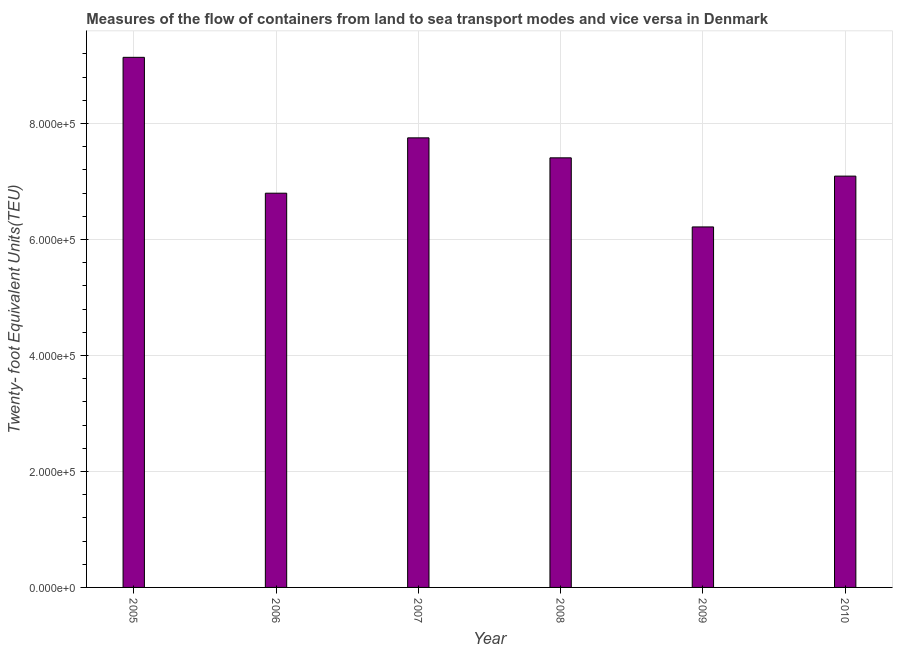Does the graph contain grids?
Ensure brevity in your answer.  Yes. What is the title of the graph?
Keep it short and to the point. Measures of the flow of containers from land to sea transport modes and vice versa in Denmark. What is the label or title of the X-axis?
Your answer should be very brief. Year. What is the label or title of the Y-axis?
Your response must be concise. Twenty- foot Equivalent Units(TEU). What is the container port traffic in 2007?
Ensure brevity in your answer.  7.75e+05. Across all years, what is the maximum container port traffic?
Your answer should be compact. 9.14e+05. Across all years, what is the minimum container port traffic?
Offer a very short reply. 6.22e+05. In which year was the container port traffic maximum?
Keep it short and to the point. 2005. What is the sum of the container port traffic?
Make the answer very short. 4.44e+06. What is the difference between the container port traffic in 2008 and 2009?
Your answer should be compact. 1.19e+05. What is the average container port traffic per year?
Offer a terse response. 7.40e+05. What is the median container port traffic?
Make the answer very short. 7.25e+05. In how many years, is the container port traffic greater than 160000 TEU?
Offer a terse response. 6. What is the ratio of the container port traffic in 2008 to that in 2009?
Offer a very short reply. 1.19. What is the difference between the highest and the second highest container port traffic?
Offer a terse response. 1.39e+05. What is the difference between the highest and the lowest container port traffic?
Keep it short and to the point. 2.92e+05. How many bars are there?
Ensure brevity in your answer.  6. Are all the bars in the graph horizontal?
Your answer should be compact. No. How many years are there in the graph?
Make the answer very short. 6. What is the Twenty- foot Equivalent Units(TEU) of 2005?
Give a very brief answer. 9.14e+05. What is the Twenty- foot Equivalent Units(TEU) of 2006?
Offer a very short reply. 6.80e+05. What is the Twenty- foot Equivalent Units(TEU) of 2007?
Your answer should be very brief. 7.75e+05. What is the Twenty- foot Equivalent Units(TEU) in 2008?
Your response must be concise. 7.41e+05. What is the Twenty- foot Equivalent Units(TEU) in 2009?
Provide a short and direct response. 6.22e+05. What is the Twenty- foot Equivalent Units(TEU) of 2010?
Offer a very short reply. 7.09e+05. What is the difference between the Twenty- foot Equivalent Units(TEU) in 2005 and 2006?
Ensure brevity in your answer.  2.34e+05. What is the difference between the Twenty- foot Equivalent Units(TEU) in 2005 and 2007?
Your answer should be compact. 1.39e+05. What is the difference between the Twenty- foot Equivalent Units(TEU) in 2005 and 2008?
Your response must be concise. 1.73e+05. What is the difference between the Twenty- foot Equivalent Units(TEU) in 2005 and 2009?
Offer a terse response. 2.92e+05. What is the difference between the Twenty- foot Equivalent Units(TEU) in 2005 and 2010?
Your answer should be very brief. 2.05e+05. What is the difference between the Twenty- foot Equivalent Units(TEU) in 2006 and 2007?
Make the answer very short. -9.54e+04. What is the difference between the Twenty- foot Equivalent Units(TEU) in 2006 and 2008?
Your answer should be compact. -6.10e+04. What is the difference between the Twenty- foot Equivalent Units(TEU) in 2006 and 2009?
Your answer should be very brief. 5.82e+04. What is the difference between the Twenty- foot Equivalent Units(TEU) in 2006 and 2010?
Offer a terse response. -2.94e+04. What is the difference between the Twenty- foot Equivalent Units(TEU) in 2007 and 2008?
Your response must be concise. 3.44e+04. What is the difference between the Twenty- foot Equivalent Units(TEU) in 2007 and 2009?
Your response must be concise. 1.54e+05. What is the difference between the Twenty- foot Equivalent Units(TEU) in 2007 and 2010?
Provide a succinct answer. 6.60e+04. What is the difference between the Twenty- foot Equivalent Units(TEU) in 2008 and 2009?
Provide a short and direct response. 1.19e+05. What is the difference between the Twenty- foot Equivalent Units(TEU) in 2008 and 2010?
Give a very brief answer. 3.15e+04. What is the difference between the Twenty- foot Equivalent Units(TEU) in 2009 and 2010?
Offer a terse response. -8.76e+04. What is the ratio of the Twenty- foot Equivalent Units(TEU) in 2005 to that in 2006?
Give a very brief answer. 1.34. What is the ratio of the Twenty- foot Equivalent Units(TEU) in 2005 to that in 2007?
Offer a very short reply. 1.18. What is the ratio of the Twenty- foot Equivalent Units(TEU) in 2005 to that in 2008?
Provide a succinct answer. 1.23. What is the ratio of the Twenty- foot Equivalent Units(TEU) in 2005 to that in 2009?
Provide a short and direct response. 1.47. What is the ratio of the Twenty- foot Equivalent Units(TEU) in 2005 to that in 2010?
Provide a succinct answer. 1.29. What is the ratio of the Twenty- foot Equivalent Units(TEU) in 2006 to that in 2007?
Give a very brief answer. 0.88. What is the ratio of the Twenty- foot Equivalent Units(TEU) in 2006 to that in 2008?
Offer a very short reply. 0.92. What is the ratio of the Twenty- foot Equivalent Units(TEU) in 2006 to that in 2009?
Offer a very short reply. 1.09. What is the ratio of the Twenty- foot Equivalent Units(TEU) in 2006 to that in 2010?
Ensure brevity in your answer.  0.96. What is the ratio of the Twenty- foot Equivalent Units(TEU) in 2007 to that in 2008?
Your answer should be compact. 1.05. What is the ratio of the Twenty- foot Equivalent Units(TEU) in 2007 to that in 2009?
Provide a short and direct response. 1.25. What is the ratio of the Twenty- foot Equivalent Units(TEU) in 2007 to that in 2010?
Keep it short and to the point. 1.09. What is the ratio of the Twenty- foot Equivalent Units(TEU) in 2008 to that in 2009?
Provide a succinct answer. 1.19. What is the ratio of the Twenty- foot Equivalent Units(TEU) in 2008 to that in 2010?
Ensure brevity in your answer.  1.04. What is the ratio of the Twenty- foot Equivalent Units(TEU) in 2009 to that in 2010?
Make the answer very short. 0.88. 